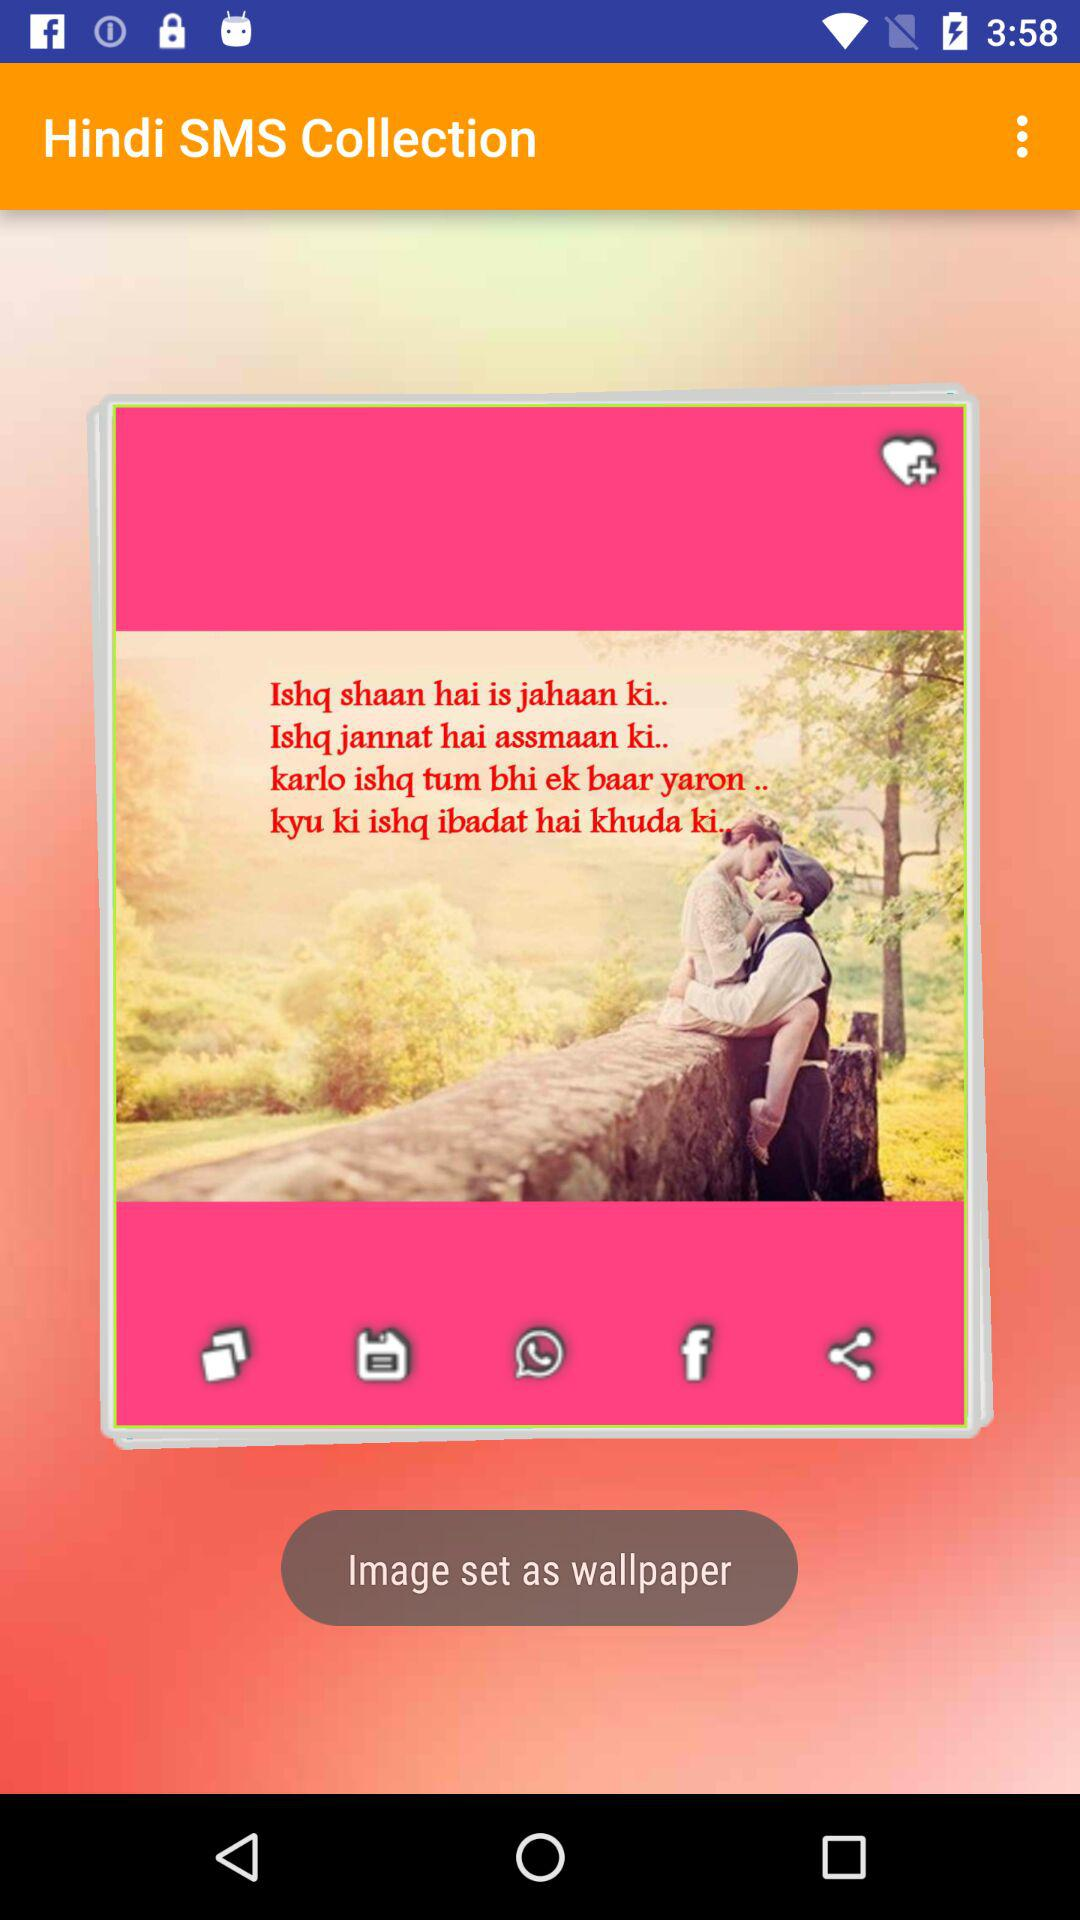What is the name of the application? The name of the application is "Hindi SMS Collection". 